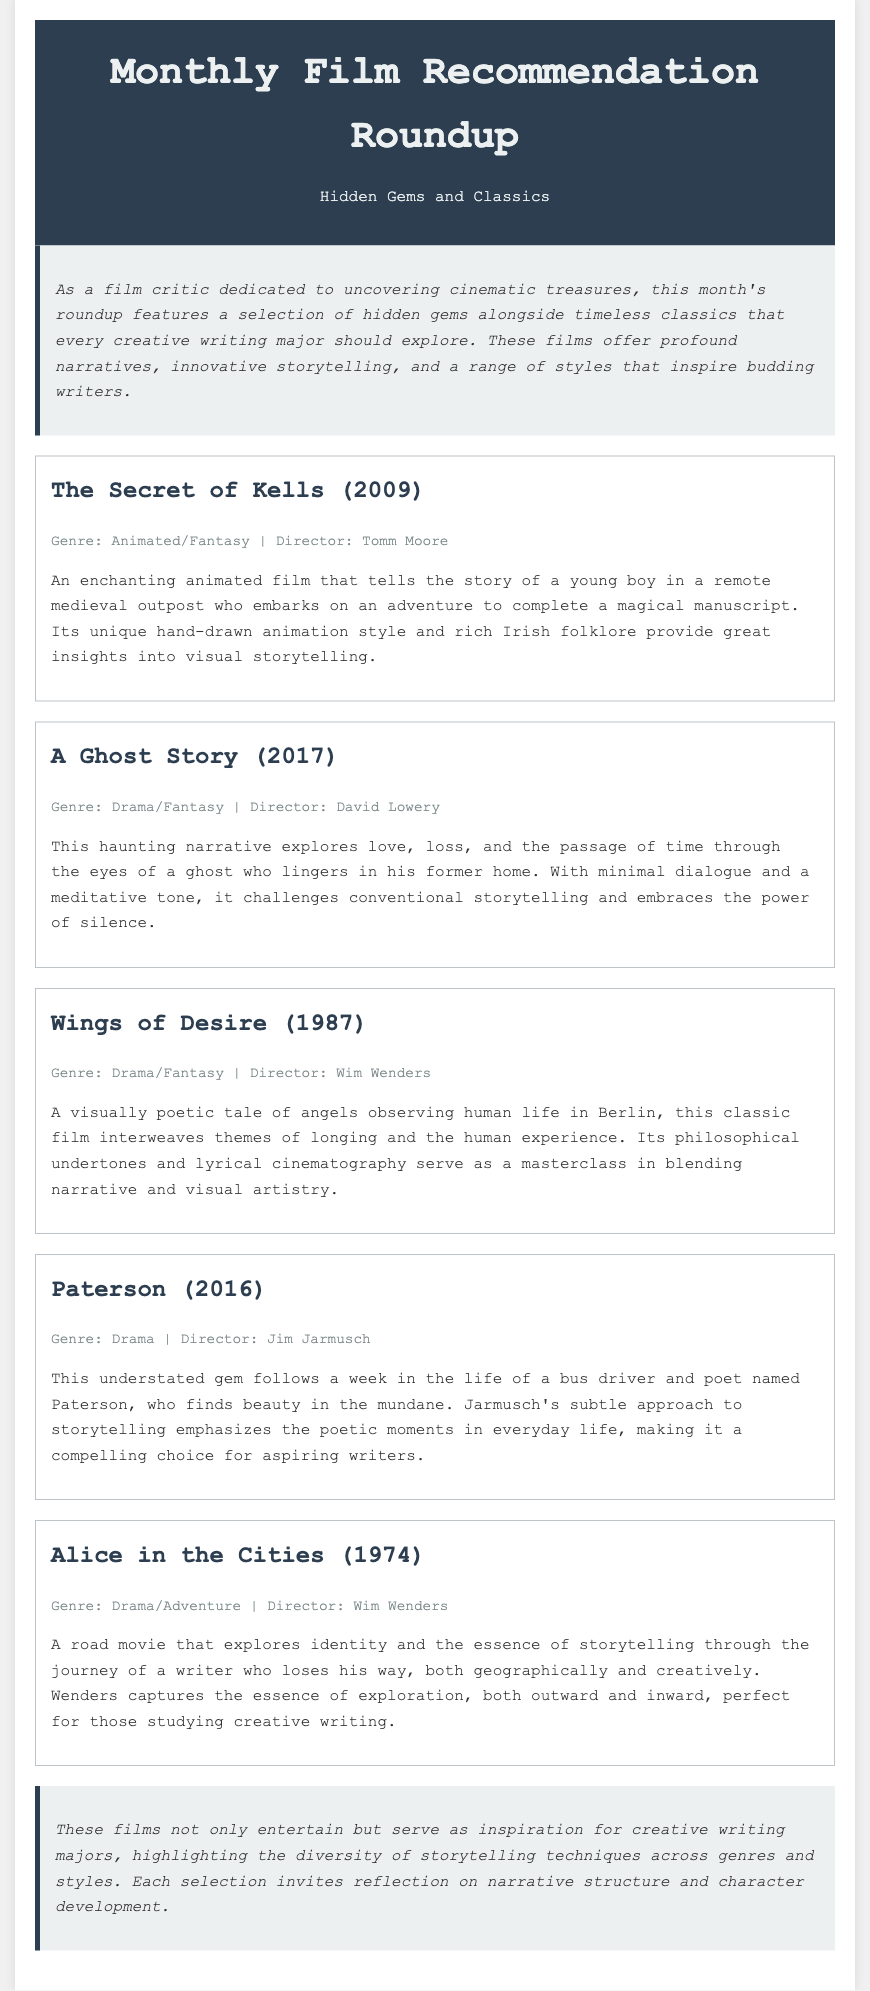What is the title of the first film recommended? The title of the first film is mentioned as the initial entry in the recommendations section.
Answer: The Secret of Kells Who directed "A Ghost Story"? The director's name is provided alongside the film title in the document.
Answer: David Lowery What genre is "Wings of Desire"? The genre of the film is listed in the film information section.
Answer: Drama/Fantasy How many films were recommended in total? The total number of films is derived from the number of entries in the recommendations section.
Answer: Five Which film explores themes of identity and storytelling? Themes are clearly stated in the film summaries, indicating which film deals with this topic.
Answer: Alice in the Cities What year was "Paterson" released? The release year is typically included with the film title and details in the document.
Answer: 2016 What is the primary focus of the introduction? The main idea in the introduction is to summarize the intent of the film recommendations.
Answer: Cinematic treasures Which film's narrative challenges conventional storytelling? This reasoning requires understanding the unique features mentioned in the film summary descriptions.
Answer: A Ghost Story 